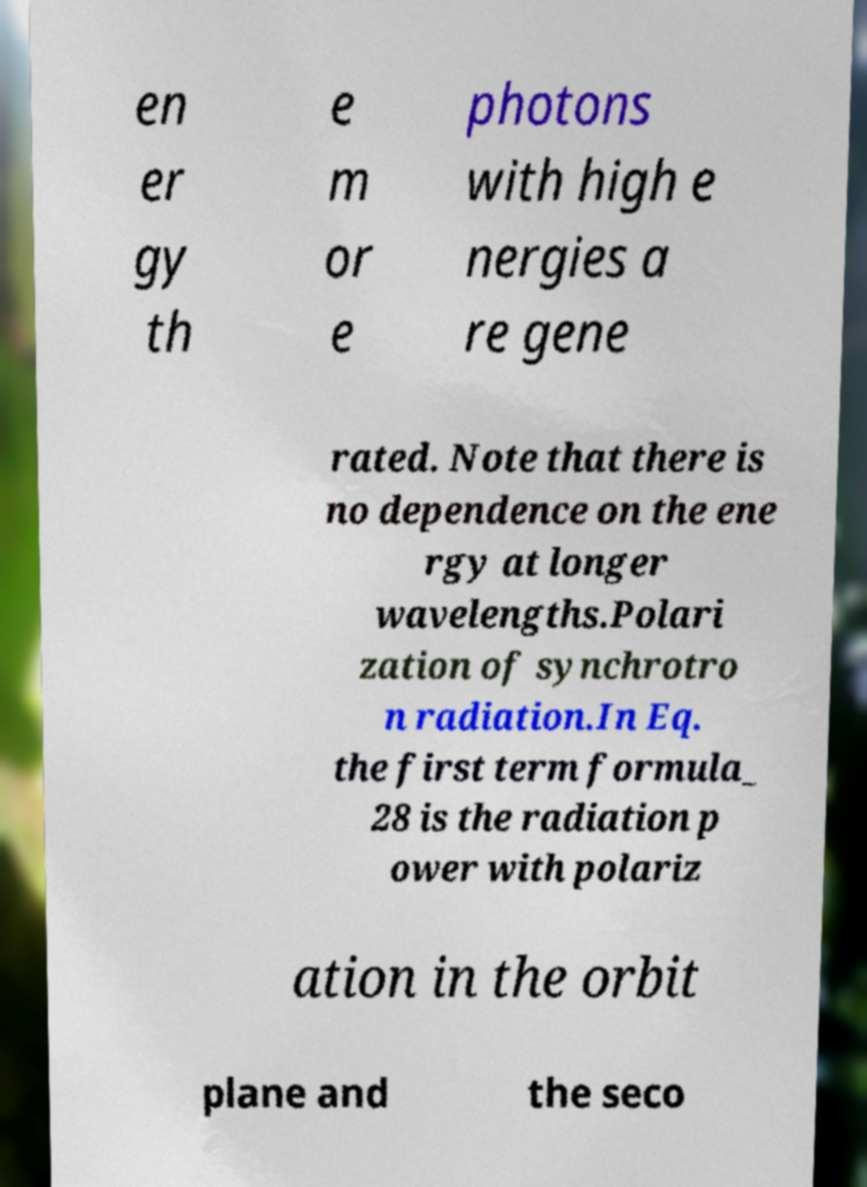What messages or text are displayed in this image? I need them in a readable, typed format. en er gy th e m or e photons with high e nergies a re gene rated. Note that there is no dependence on the ene rgy at longer wavelengths.Polari zation of synchrotro n radiation.In Eq. the first term formula_ 28 is the radiation p ower with polariz ation in the orbit plane and the seco 